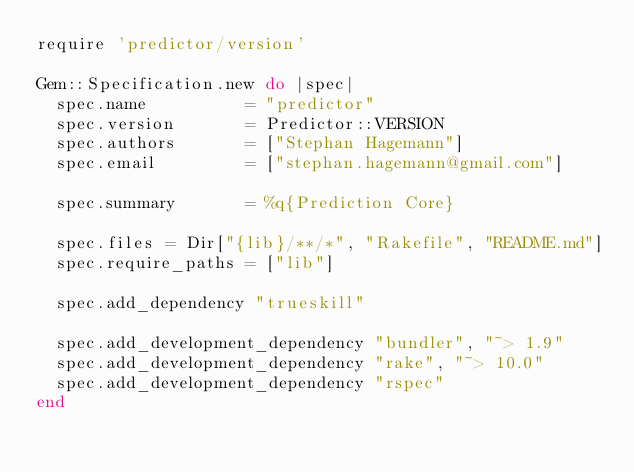<code> <loc_0><loc_0><loc_500><loc_500><_Ruby_>require 'predictor/version'

Gem::Specification.new do |spec|
  spec.name          = "predictor"
  spec.version       = Predictor::VERSION
  spec.authors       = ["Stephan Hagemann"]
  spec.email         = ["stephan.hagemann@gmail.com"]

  spec.summary       = %q{Prediction Core}

  spec.files = Dir["{lib}/**/*", "Rakefile", "README.md"]
  spec.require_paths = ["lib"]

  spec.add_dependency "trueskill"

  spec.add_development_dependency "bundler", "~> 1.9"
  spec.add_development_dependency "rake", "~> 10.0"
  spec.add_development_dependency "rspec"
end
</code> 